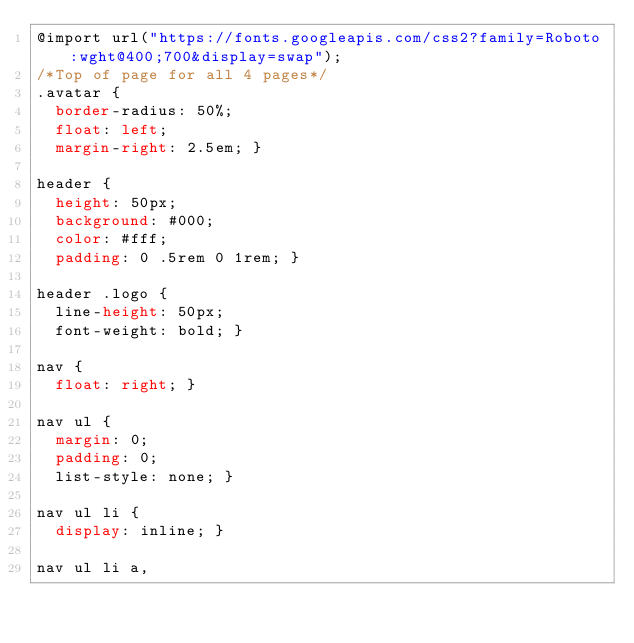<code> <loc_0><loc_0><loc_500><loc_500><_CSS_>@import url("https://fonts.googleapis.com/css2?family=Roboto:wght@400;700&display=swap");
/*Top of page for all 4 pages*/
.avatar {
  border-radius: 50%;
  float: left;
  margin-right: 2.5em; }

header {
  height: 50px;
  background: #000;
  color: #fff;
  padding: 0 .5rem 0 1rem; }

header .logo {
  line-height: 50px;
  font-weight: bold; }

nav {
  float: right; }

nav ul {
  margin: 0;
  padding: 0;
  list-style: none; }

nav ul li {
  display: inline; }

nav ul li a,</code> 